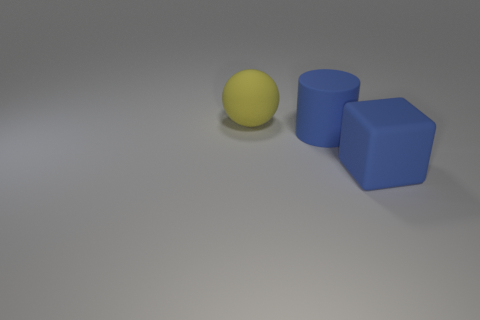Add 2 tiny green metal objects. How many objects exist? 5 Subtract all cylinders. How many objects are left? 2 Subtract 0 green balls. How many objects are left? 3 Subtract all balls. Subtract all gray cylinders. How many objects are left? 2 Add 3 yellow rubber objects. How many yellow rubber objects are left? 4 Add 1 large yellow matte objects. How many large yellow matte objects exist? 2 